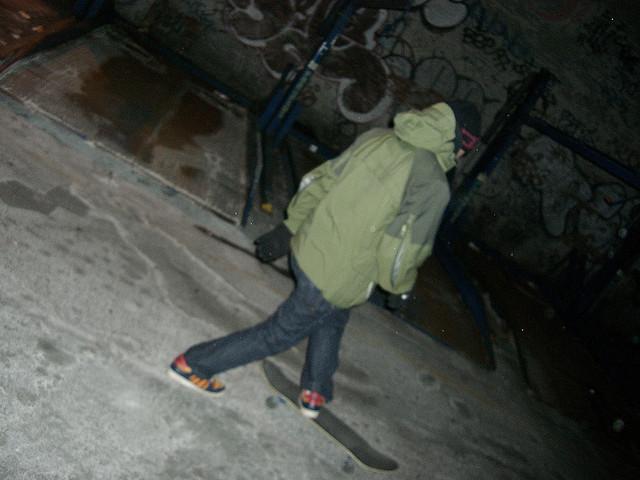What's on the ground?
Quick response, please. Cement. Is the person wearing shorts?
Be succinct. No. What age group does this person belong in?
Quick response, please. Teens. Is it hot in there?
Write a very short answer. No. Is there stain on the ground?
Concise answer only. Yes. Is the man tired?
Write a very short answer. No. How many legs are in the image?
Concise answer only. 2. Does this look like a safe area?
Give a very brief answer. No. What color are his gloves?
Be succinct. Black. What type of coat is the woman wearing?
Answer briefly. Snow. 